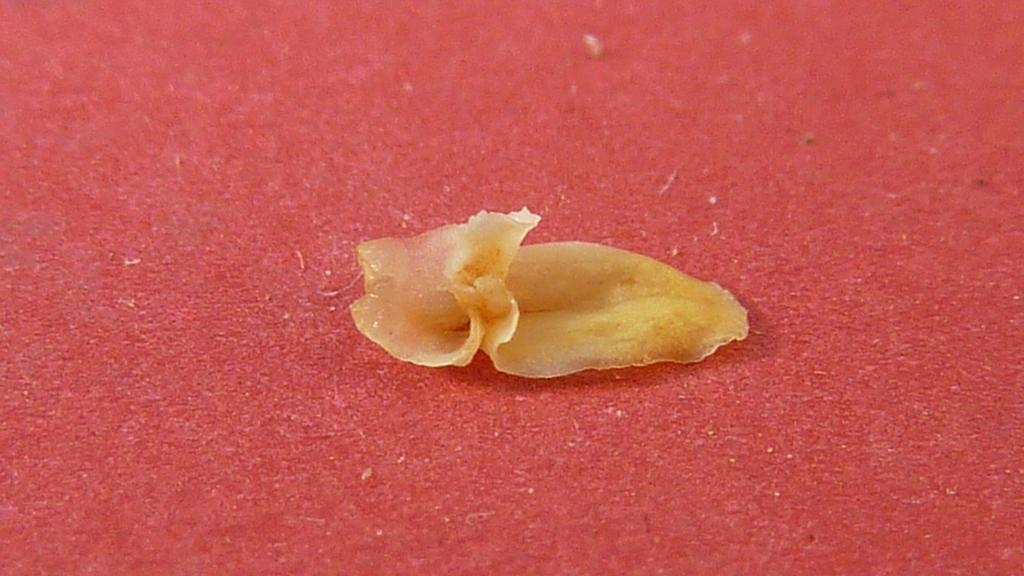What type of sea creature is in the image? There is a small jellyfish in the image. What is the color of the carpet on which the jellyfish is placed? The jellyfish is on a red color carpet. What type of sidewalk is visible in the image? There is no sidewalk present in the image; it features a small jellyfish on a red color carpet. 